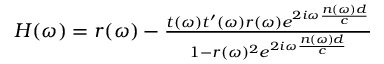Convert formula to latex. <formula><loc_0><loc_0><loc_500><loc_500>\begin{array} { r } { \begin{array} { r } { H ( \omega ) = r ( \omega ) - \frac { t ( \omega ) t ^ { \prime } ( \omega ) r ( \omega ) e ^ { 2 i \omega \frac { n ( \omega ) d } { c } } } { 1 - r ( \omega ) ^ { 2 } e ^ { 2 i \omega \frac { n ( \omega ) d } { c } } } } \end{array} } \end{array}</formula> 